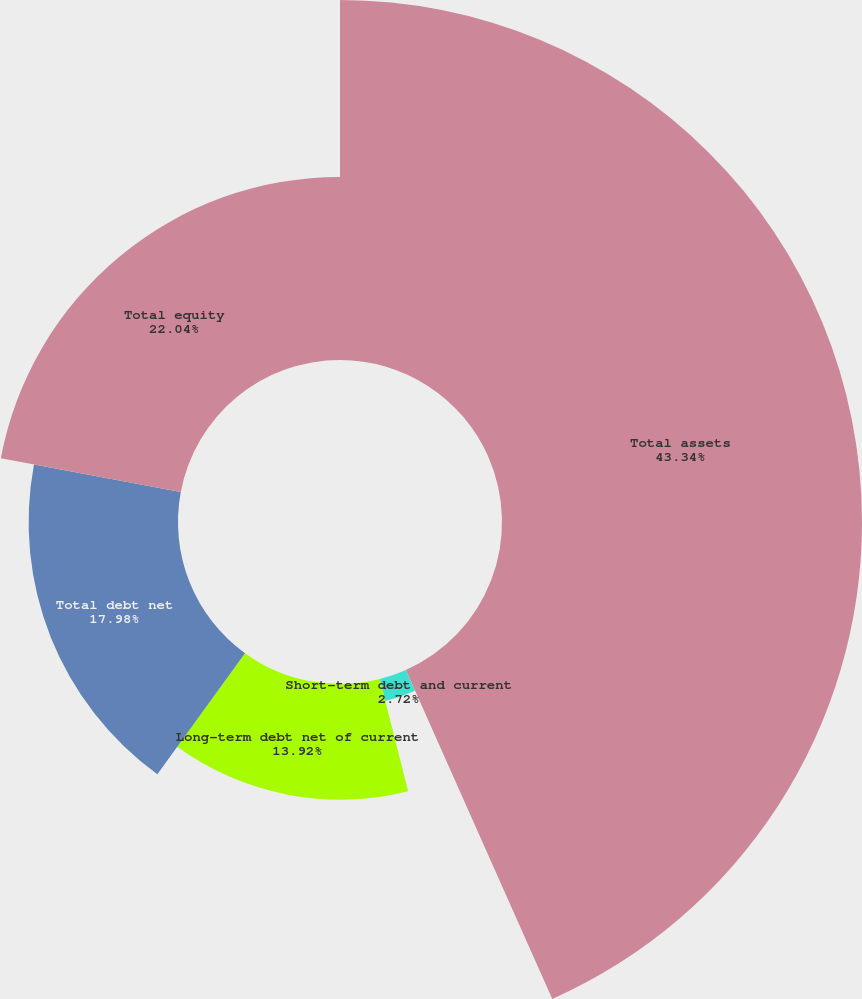Convert chart. <chart><loc_0><loc_0><loc_500><loc_500><pie_chart><fcel>Total assets<fcel>Short-term debt and current<fcel>Long-term debt net of current<fcel>Total debt net<fcel>Total equity<nl><fcel>43.33%<fcel>2.72%<fcel>13.92%<fcel>17.98%<fcel>22.04%<nl></chart> 